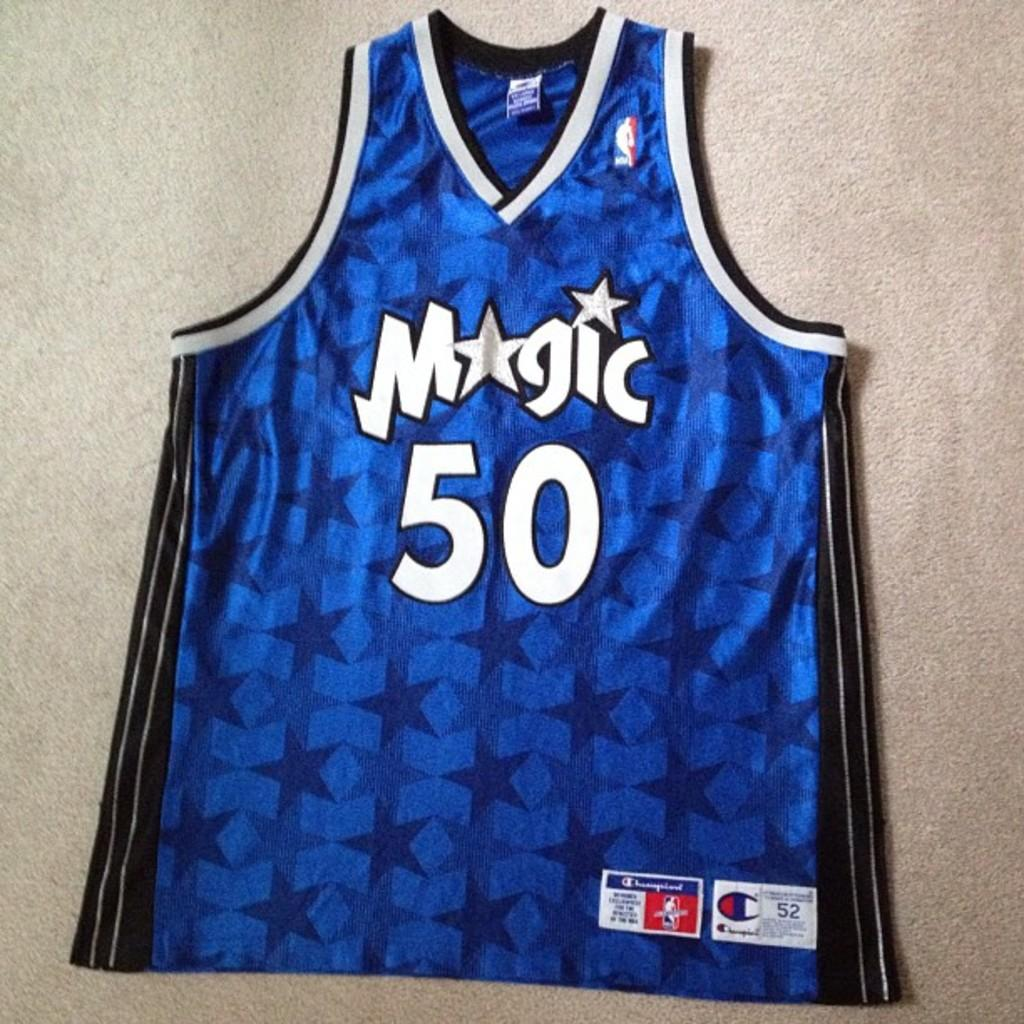<image>
Write a terse but informative summary of the picture. Blue basketball jersey which says Magic on it. 